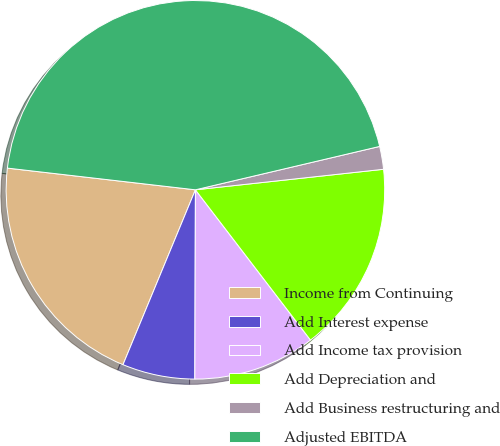Convert chart to OTSL. <chart><loc_0><loc_0><loc_500><loc_500><pie_chart><fcel>Income from Continuing<fcel>Add Interest expense<fcel>Add Income tax provision<fcel>Add Depreciation and<fcel>Add Business restructuring and<fcel>Adjusted EBITDA<nl><fcel>20.58%<fcel>6.2%<fcel>10.45%<fcel>16.33%<fcel>1.95%<fcel>44.49%<nl></chart> 